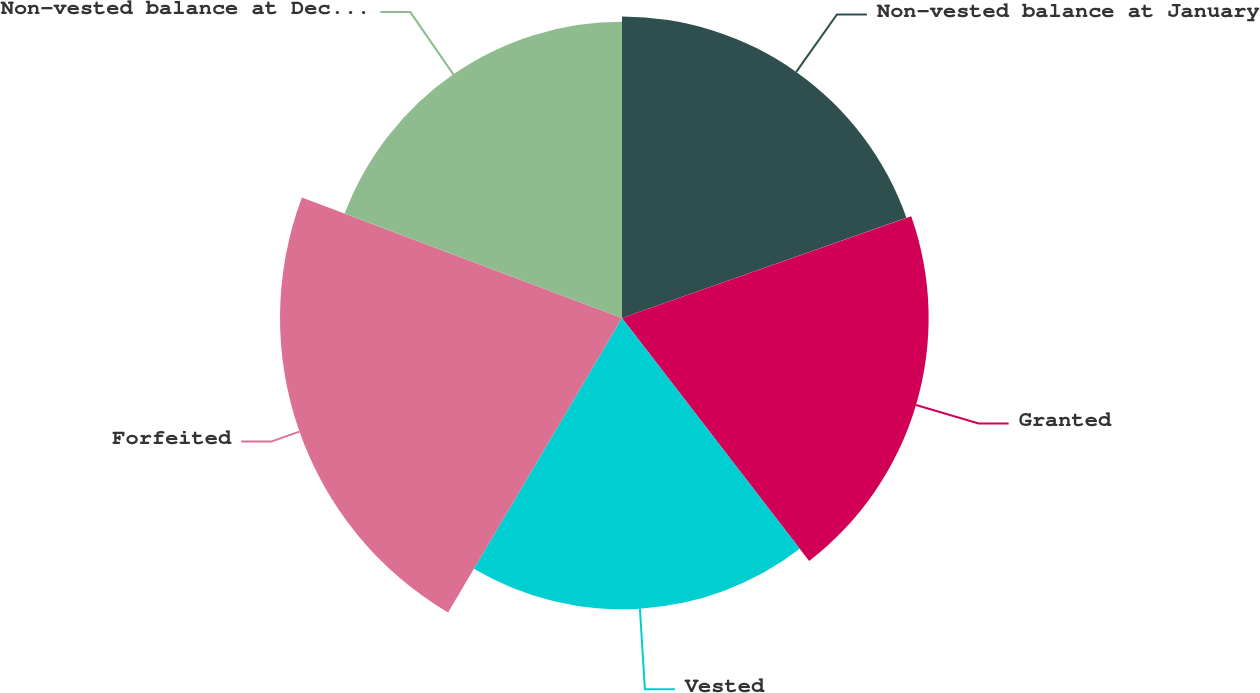<chart> <loc_0><loc_0><loc_500><loc_500><pie_chart><fcel>Non-vested balance at January<fcel>Granted<fcel>Vested<fcel>Forfeited<fcel>Non-vested balance at December<nl><fcel>19.61%<fcel>19.94%<fcel>18.94%<fcel>22.24%<fcel>19.27%<nl></chart> 